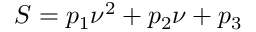<formula> <loc_0><loc_0><loc_500><loc_500>S = p _ { 1 } \nu ^ { 2 } + p _ { 2 } \nu + p _ { 3 }</formula> 